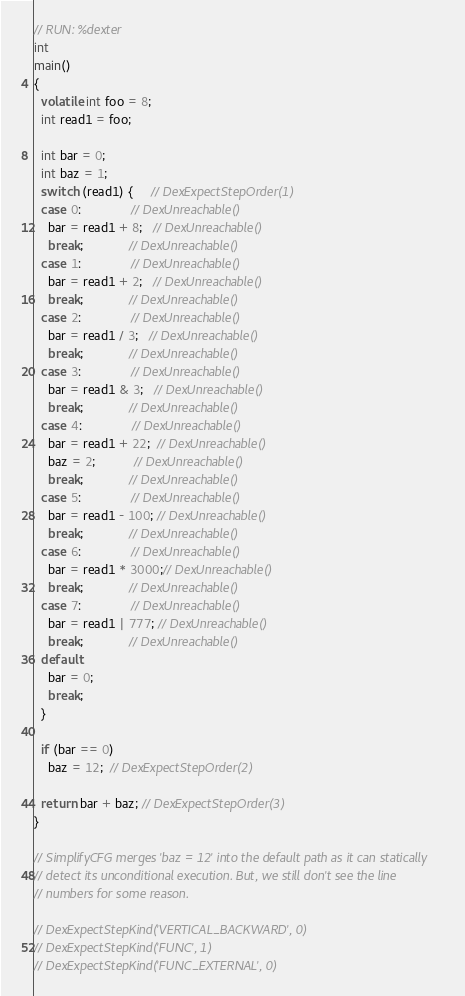Convert code to text. <code><loc_0><loc_0><loc_500><loc_500><_C++_>// RUN: %dexter
int
main()
{
  volatile int foo = 8;
  int read1 = foo;

  int bar = 0;
  int baz = 1;
  switch (read1) {     // DexExpectStepOrder(1)
  case 0:              // DexUnreachable()
    bar = read1 + 8;   // DexUnreachable()
    break;             // DexUnreachable()
  case 1:              // DexUnreachable()
    bar = read1 + 2;   // DexUnreachable()
    break;             // DexUnreachable()
  case 2:              // DexUnreachable()
    bar = read1 / 3;   // DexUnreachable()
    break;             // DexUnreachable()
  case 3:              // DexUnreachable()
    bar = read1 & 3;   // DexUnreachable()
    break;             // DexUnreachable()
  case 4:              // DexUnreachable()
    bar = read1 + 22;  // DexUnreachable()
    baz = 2;           // DexUnreachable()
    break;             // DexUnreachable()
  case 5:              // DexUnreachable()
    bar = read1 - 100; // DexUnreachable()
    break;             // DexUnreachable()
  case 6:              // DexUnreachable()
    bar = read1 * 3000;// DexUnreachable()
    break;             // DexUnreachable()
  case 7:              // DexUnreachable()
    bar = read1 | 777; // DexUnreachable()
    break;             // DexUnreachable()
  default:
    bar = 0;
    break;
  }

  if (bar == 0)
    baz = 12;  // DexExpectStepOrder(2)

  return bar + baz; // DexExpectStepOrder(3)
}

// SimplifyCFG merges 'baz = 12' into the default path as it can statically
// detect its unconditional execution. But, we still don't see the line
// numbers for some reason.

// DexExpectStepKind('VERTICAL_BACKWARD', 0)
// DexExpectStepKind('FUNC', 1)
// DexExpectStepKind('FUNC_EXTERNAL', 0)
</code> 